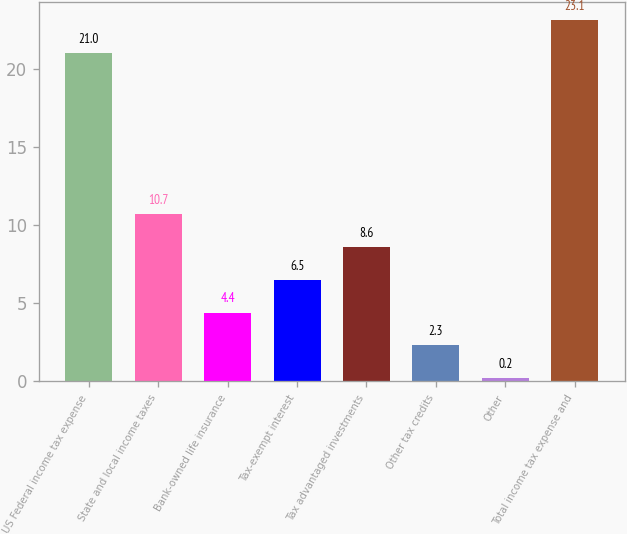Convert chart to OTSL. <chart><loc_0><loc_0><loc_500><loc_500><bar_chart><fcel>US Federal income tax expense<fcel>State and local income taxes<fcel>Bank-owned life insurance<fcel>Tax-exempt interest<fcel>Tax advantaged investments<fcel>Other tax credits<fcel>Other<fcel>Total income tax expense and<nl><fcel>21<fcel>10.7<fcel>4.4<fcel>6.5<fcel>8.6<fcel>2.3<fcel>0.2<fcel>23.1<nl></chart> 